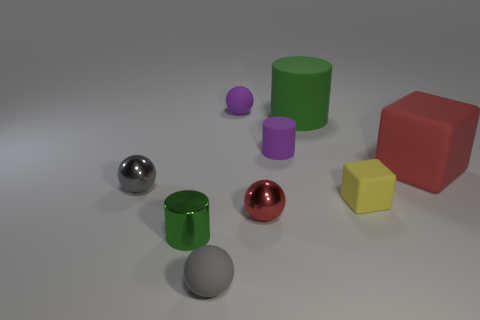How many other objects are the same color as the tiny shiny cylinder?
Provide a short and direct response. 1. Is the material of the small yellow thing the same as the green cylinder that is on the right side of the purple ball?
Your answer should be compact. Yes. There is a tiny gray thing that is behind the tiny ball in front of the small shiny cylinder; what number of green things are to the left of it?
Keep it short and to the point. 0. Is the number of tiny rubber spheres that are behind the yellow matte thing less than the number of green metal cylinders in front of the big green matte cylinder?
Keep it short and to the point. No. How many other objects are the same material as the small cube?
Your response must be concise. 5. There is a cylinder that is the same size as the red rubber cube; what is its material?
Offer a terse response. Rubber. What number of green things are either shiny spheres or tiny spheres?
Your answer should be compact. 0. The small object that is behind the yellow matte thing and to the right of the purple ball is what color?
Your answer should be compact. Purple. Is the green thing behind the small gray shiny ball made of the same material as the green object that is on the left side of the green rubber cylinder?
Provide a succinct answer. No. Is the number of tiny matte things that are on the left side of the small red shiny sphere greater than the number of tiny purple objects that are to the right of the tiny yellow rubber cube?
Your answer should be very brief. Yes. 